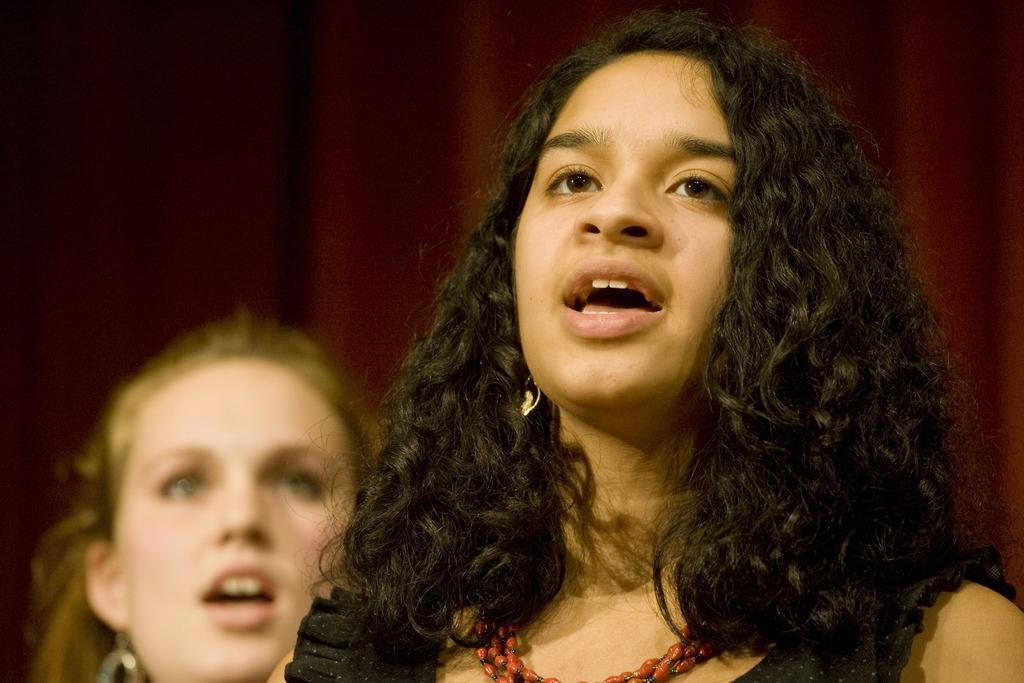Can you describe this image briefly? This image consists of two persons. On the right, the girl is wearing a black dress. It looks like she's singing. In the background, we can see a curtain in maroon color. 